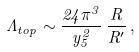Convert formula to latex. <formula><loc_0><loc_0><loc_500><loc_500>\Lambda _ { t o p } \sim \frac { 2 4 \pi ^ { 3 } } { y _ { 5 } ^ { 2 } } \, \frac { R } { R ^ { \prime } } \, ,</formula> 